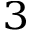<formula> <loc_0><loc_0><loc_500><loc_500>_ { 3 }</formula> 